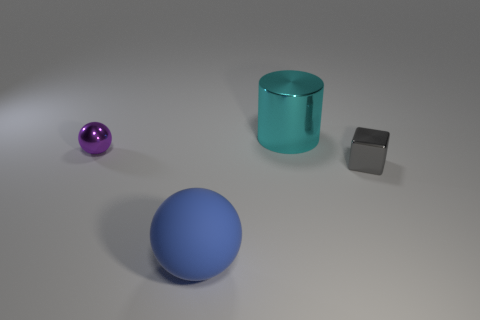Add 1 tiny blocks. How many objects exist? 5 Subtract all blue balls. How many balls are left? 1 Subtract 1 spheres. How many spheres are left? 1 Subtract all gray cubes. How many purple balls are left? 1 Add 1 purple things. How many purple things are left? 2 Add 4 gray blocks. How many gray blocks exist? 5 Subtract 0 purple blocks. How many objects are left? 4 Subtract all blue cylinders. Subtract all gray blocks. How many cylinders are left? 1 Subtract all small things. Subtract all balls. How many objects are left? 0 